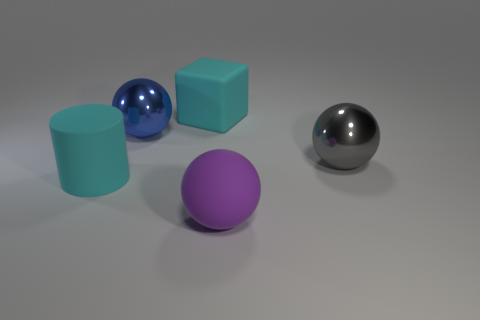What number of big rubber cylinders are the same color as the matte block?
Offer a very short reply. 1. Is the big purple ball made of the same material as the cyan cylinder?
Provide a succinct answer. Yes. There is a large matte thing that is behind the cyan cylinder; what number of purple things are on the left side of it?
Offer a terse response. 0. Does the big matte object on the left side of the cyan block have the same color as the matte block?
Give a very brief answer. Yes. How many things are large yellow spheres or shiny objects to the right of the rubber sphere?
Give a very brief answer. 1. There is a big shiny object behind the gray ball; does it have the same shape as the large metallic object that is right of the cyan matte cube?
Give a very brief answer. Yes. Is there anything else that is the same color as the cylinder?
Your response must be concise. Yes. There is a big gray object that is made of the same material as the big blue sphere; what shape is it?
Provide a succinct answer. Sphere. What material is the big ball that is to the right of the blue sphere and behind the big cyan cylinder?
Offer a terse response. Metal. Do the large matte block and the rubber cylinder have the same color?
Your answer should be very brief. Yes. 